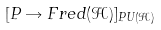<formula> <loc_0><loc_0><loc_500><loc_500>[ P \rightarrow F r e d ( { \mathcal { H } } ) ] _ { P U ( { \mathcal { H } } ) }</formula> 